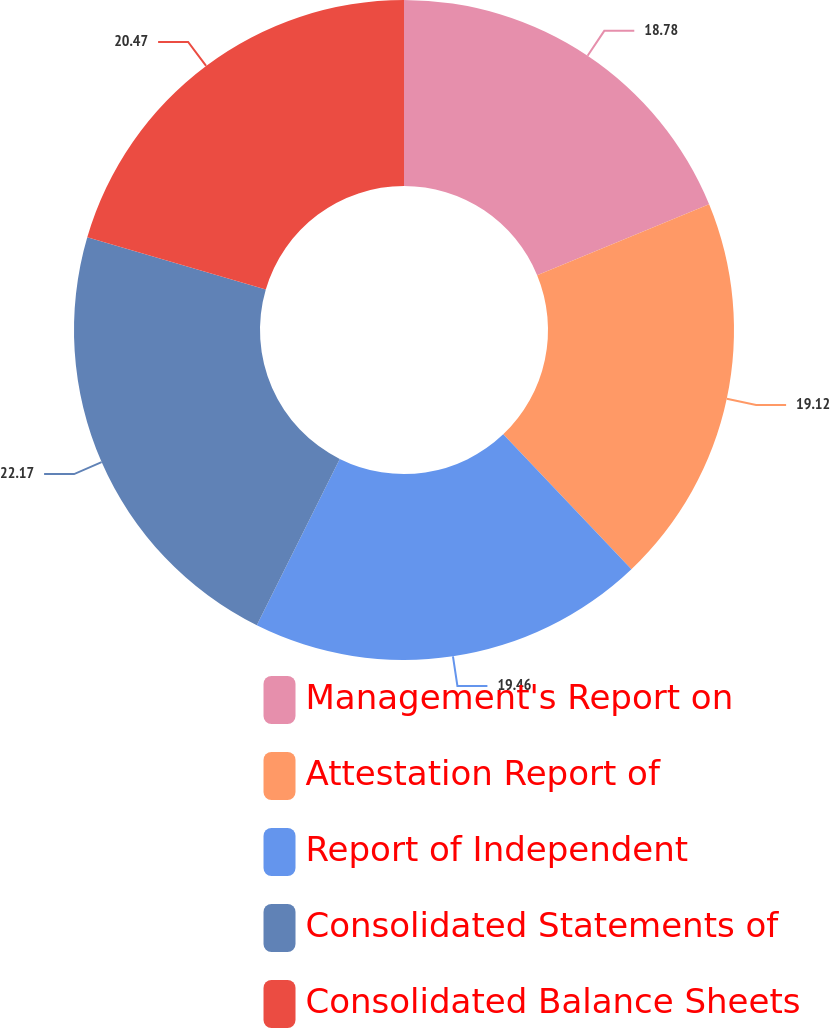<chart> <loc_0><loc_0><loc_500><loc_500><pie_chart><fcel>Management's Report on<fcel>Attestation Report of<fcel>Report of Independent<fcel>Consolidated Statements of<fcel>Consolidated Balance Sheets<nl><fcel>18.78%<fcel>19.12%<fcel>19.46%<fcel>22.17%<fcel>20.47%<nl></chart> 